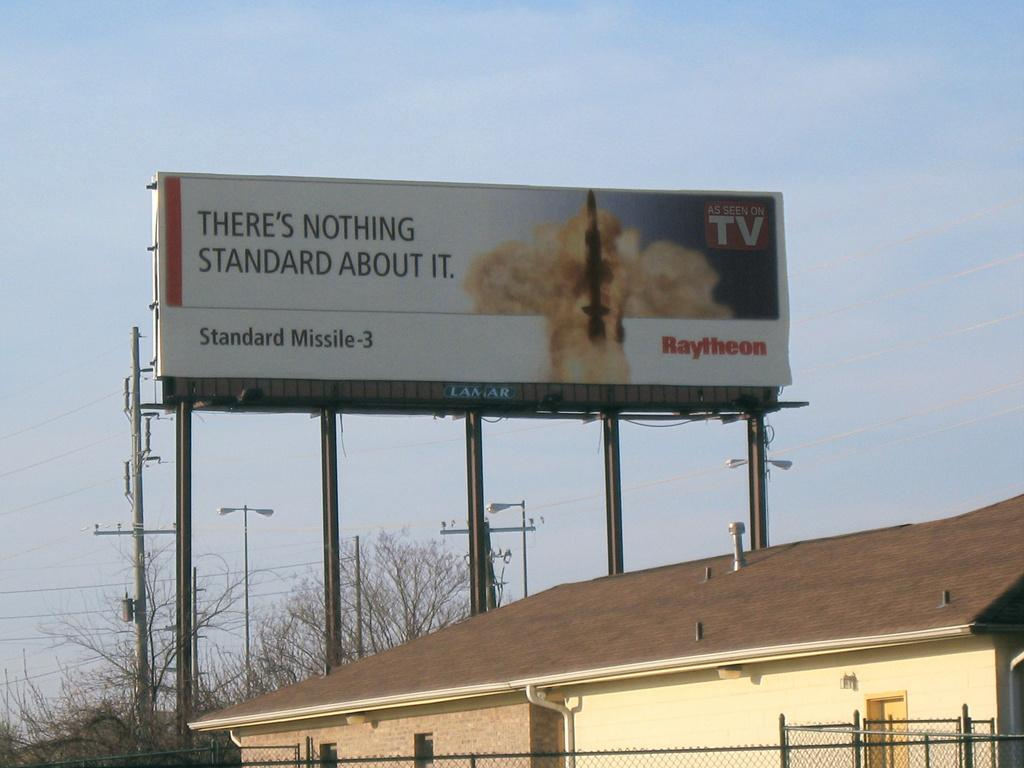<image>
Provide a brief description of the given image. a bill board for Standard Missile-3 by Raytheon 